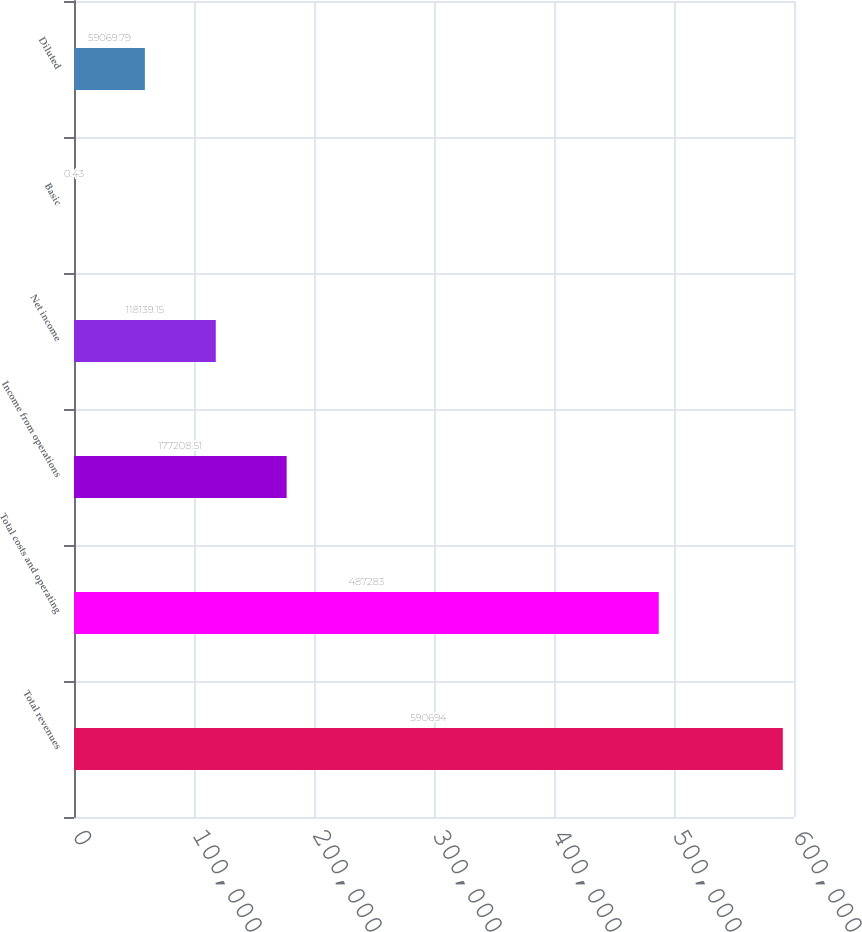Convert chart to OTSL. <chart><loc_0><loc_0><loc_500><loc_500><bar_chart><fcel>Total revenues<fcel>Total costs and operating<fcel>Income from operations<fcel>Net income<fcel>Basic<fcel>Diluted<nl><fcel>590694<fcel>487283<fcel>177209<fcel>118139<fcel>0.43<fcel>59069.8<nl></chart> 